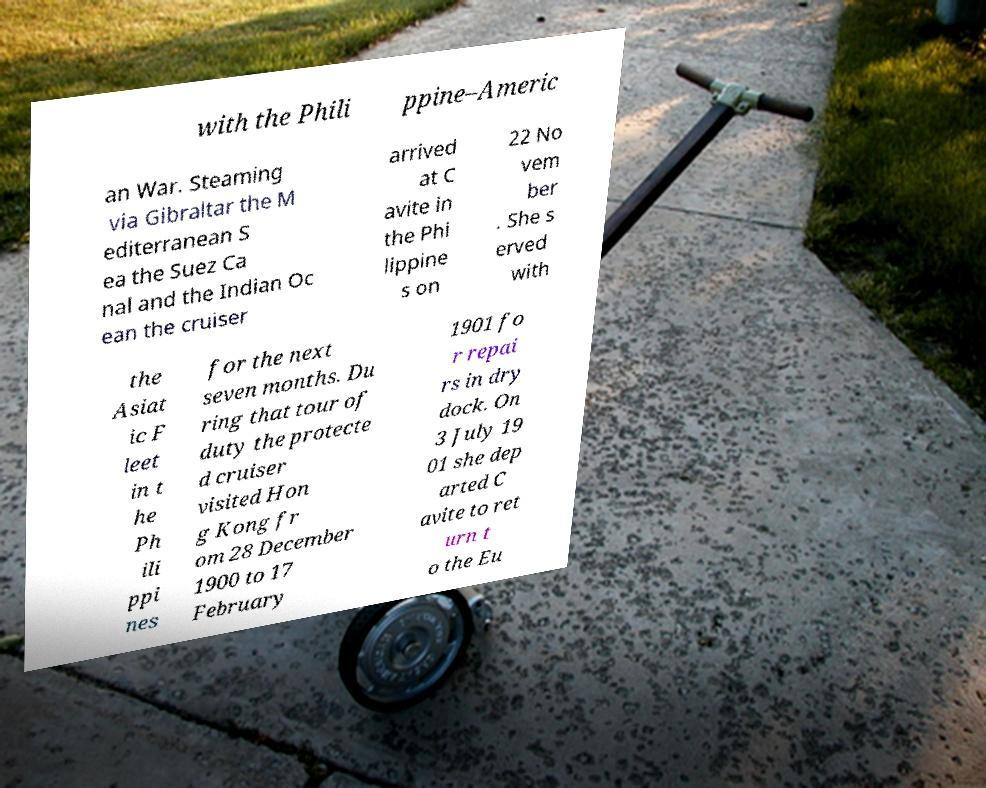Please identify and transcribe the text found in this image. with the Phili ppine–Americ an War. Steaming via Gibraltar the M editerranean S ea the Suez Ca nal and the Indian Oc ean the cruiser arrived at C avite in the Phi lippine s on 22 No vem ber . She s erved with the Asiat ic F leet in t he Ph ili ppi nes for the next seven months. Du ring that tour of duty the protecte d cruiser visited Hon g Kong fr om 28 December 1900 to 17 February 1901 fo r repai rs in dry dock. On 3 July 19 01 she dep arted C avite to ret urn t o the Eu 